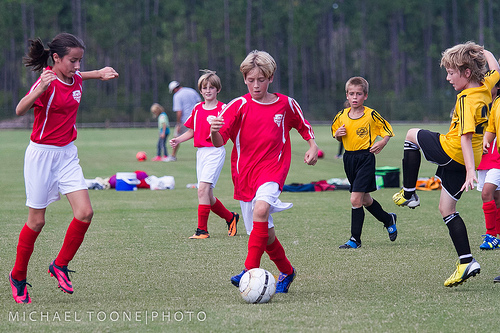<image>
Is there a boy in the grass? No. The boy is not contained within the grass. These objects have a different spatial relationship. 